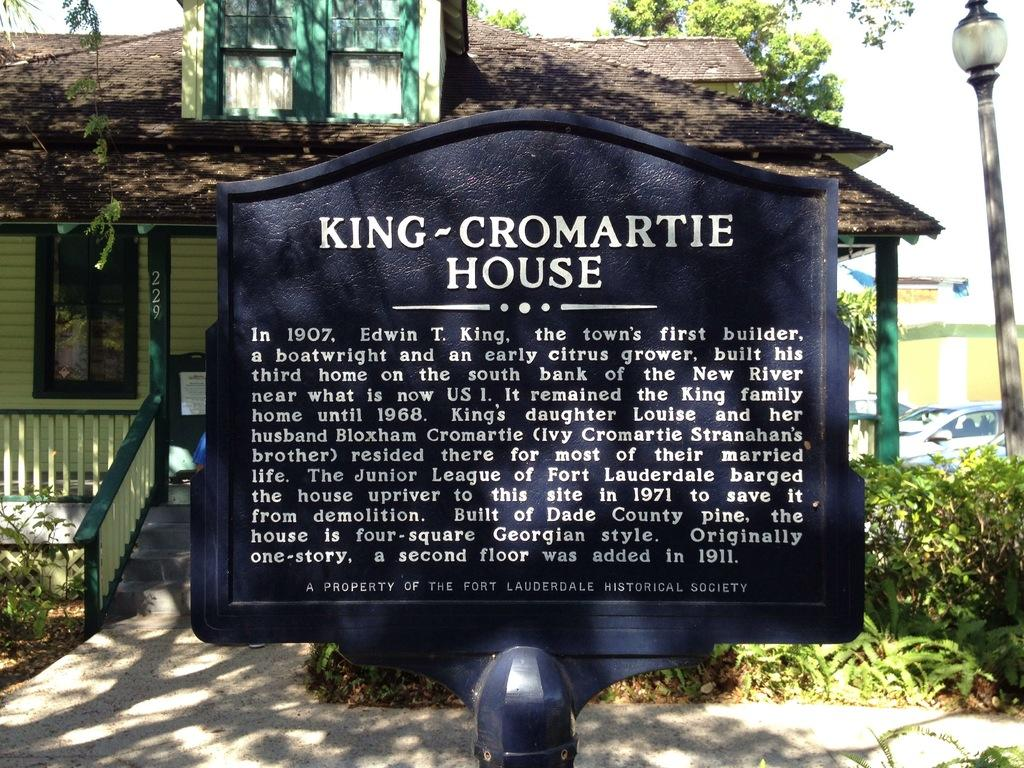What is written on the blackboard in the image? There is a blackboard with text in the image. What can be seen in the background of the image? There is a home, trees, cars, and a pole in the background of the image. What type of meal is being prepared on the blackboard in the image? There is no meal being prepared on the blackboard in the image; it is a blackboard with text. What type of stitch is being used to attach the pole to the ground in the image? There is no stitching involved in the image; the pole is simply standing in the background. 